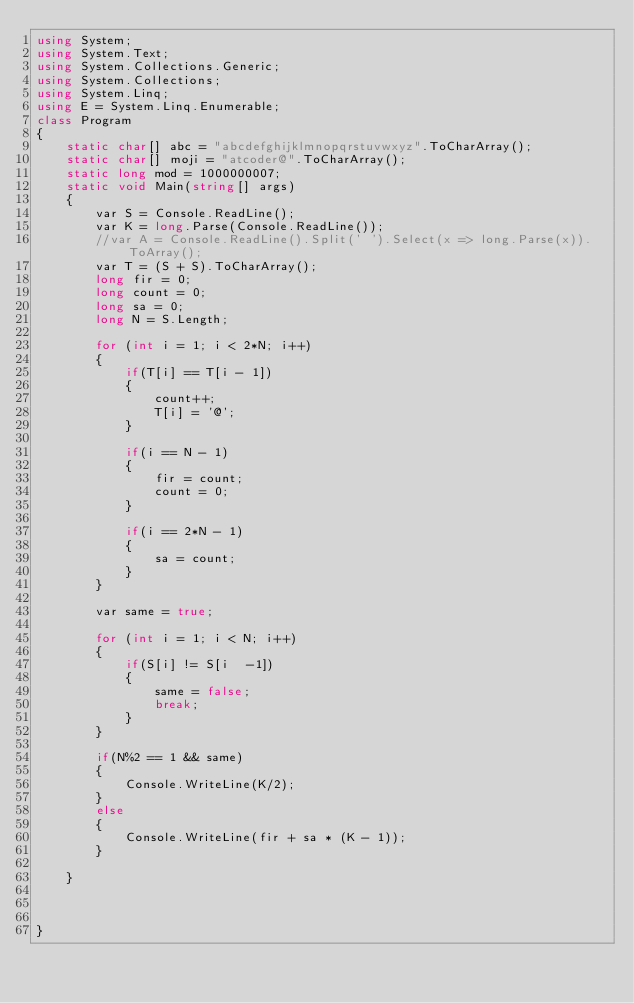Convert code to text. <code><loc_0><loc_0><loc_500><loc_500><_C#_>using System;
using System.Text;
using System.Collections.Generic;
using System.Collections;
using System.Linq;
using E = System.Linq.Enumerable;
class Program
{
    static char[] abc = "abcdefghijklmnopqrstuvwxyz".ToCharArray();
    static char[] moji = "atcoder@".ToCharArray();
    static long mod = 1000000007;
    static void Main(string[] args)
    {
        var S = Console.ReadLine();
        var K = long.Parse(Console.ReadLine());
        //var A = Console.ReadLine().Split(' ').Select(x => long.Parse(x)).ToArray();
        var T = (S + S).ToCharArray();
        long fir = 0;
        long count = 0;
        long sa = 0;
        long N = S.Length;

        for (int i = 1; i < 2*N; i++)
        {
            if(T[i] == T[i - 1])
            {
                count++;
                T[i] = '@';
            }

            if(i == N - 1)
            {
                fir = count;
                count = 0;
            }

            if(i == 2*N - 1)
            {
                sa = count;
            }
        }

        var same = true;

        for (int i = 1; i < N; i++)
        {
            if(S[i] != S[i  -1])
            {
                same = false;
                break;
            }
        }

        if(N%2 == 1 && same)
        {
            Console.WriteLine(K/2);
        }
        else
        {
            Console.WriteLine(fir + sa * (K - 1));
        }
        
    }
        

    
}
</code> 